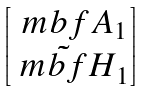<formula> <loc_0><loc_0><loc_500><loc_500>\begin{bmatrix} \ m b f { A } _ { 1 } \\ \tilde { \ m b f { H } } _ { 1 } \end{bmatrix}</formula> 